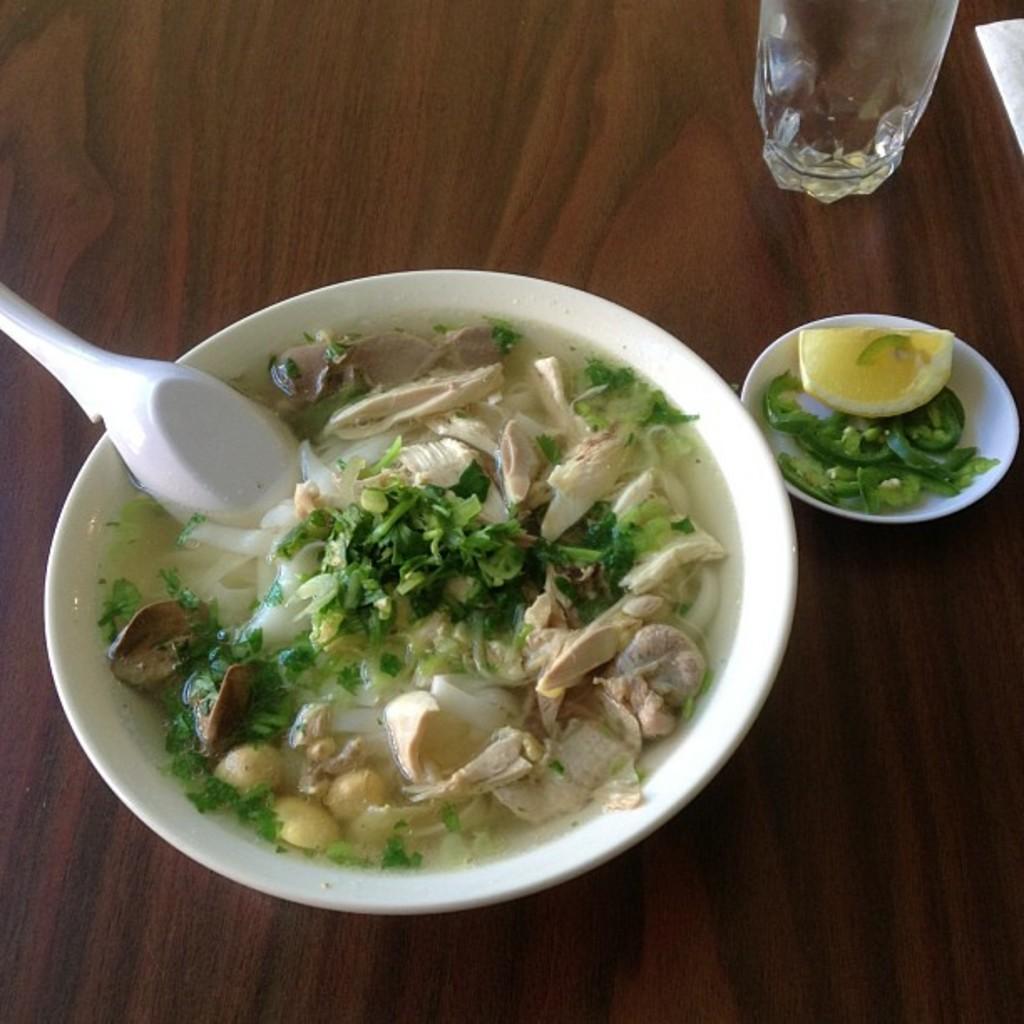Can you describe this image briefly? There are food items and a white color spoon in the water which is in the white color bowl. This bowl is on a wooden table on which, there is a saucer which is having food items and there is a glass. 